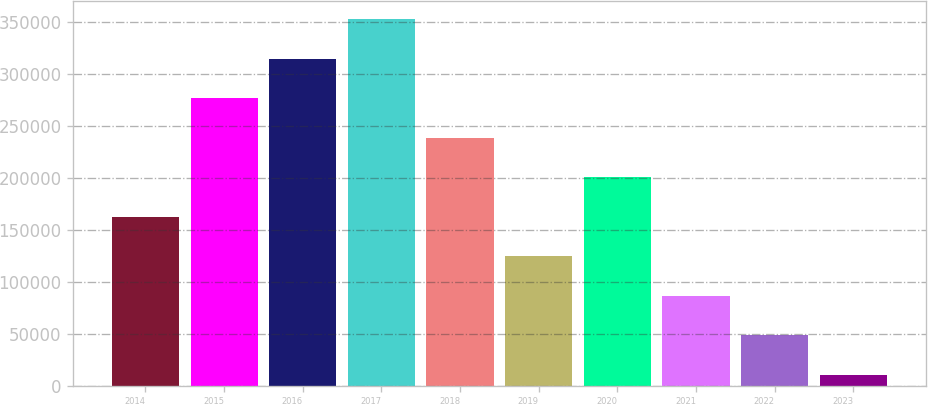Convert chart. <chart><loc_0><loc_0><loc_500><loc_500><bar_chart><fcel>2014<fcel>2015<fcel>2016<fcel>2017<fcel>2018<fcel>2019<fcel>2020<fcel>2021<fcel>2022<fcel>2023<nl><fcel>162446<fcel>276433<fcel>314429<fcel>352425<fcel>238437<fcel>124450<fcel>200442<fcel>86453.8<fcel>48457.9<fcel>10462<nl></chart> 